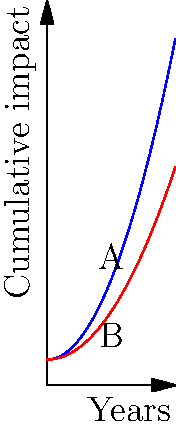The graph shows the cumulative impact of gender bias on research output over time for female (blue curve) and male (red curve) researchers in higher education. The area between the curves represents the difference in cumulative impact due to gender bias. Calculate the difference in cumulative impact between female and male researchers over a 5-year period, given that the functions for the curves are:

Female: $f(x) = 0.5x^2 + 1$
Male: $g(x) = 0.3x^2 + 1$

where $x$ represents years and $y$ represents cumulative impact. To find the difference in cumulative impact, we need to calculate the area between the two curves over the 5-year period. This can be done using integral calculus:

1. Set up the integral:
   $$\int_0^5 [f(x) - g(x)] dx$$

2. Substitute the functions:
   $$\int_0^5 [(0.5x^2 + 1) - (0.3x^2 + 1)] dx$$

3. Simplify:
   $$\int_0^5 (0.5x^2 - 0.3x^2) dx = \int_0^5 0.2x^2 dx$$

4. Integrate:
   $$[0.2 \cdot \frac{x^3}{3}]_0^5$$

5. Evaluate the integral:
   $$0.2 \cdot \frac{5^3}{3} - 0.2 \cdot \frac{0^3}{3} = 0.2 \cdot \frac{125}{3} = \frac{25}{3}$$

The difference in cumulative impact over 5 years is $\frac{25}{3}$ units.
Answer: $\frac{25}{3}$ units 